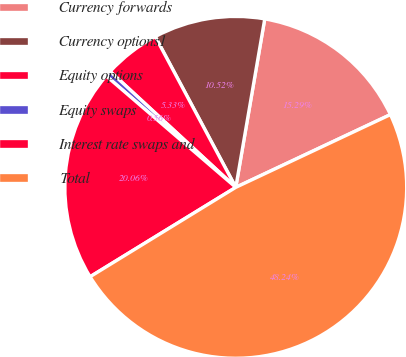Convert chart to OTSL. <chart><loc_0><loc_0><loc_500><loc_500><pie_chart><fcel>Currency forwards<fcel>Currency options1<fcel>Equity options<fcel>Equity swaps<fcel>Interest rate swaps and<fcel>Total<nl><fcel>15.29%<fcel>10.52%<fcel>5.33%<fcel>0.56%<fcel>20.06%<fcel>48.24%<nl></chart> 